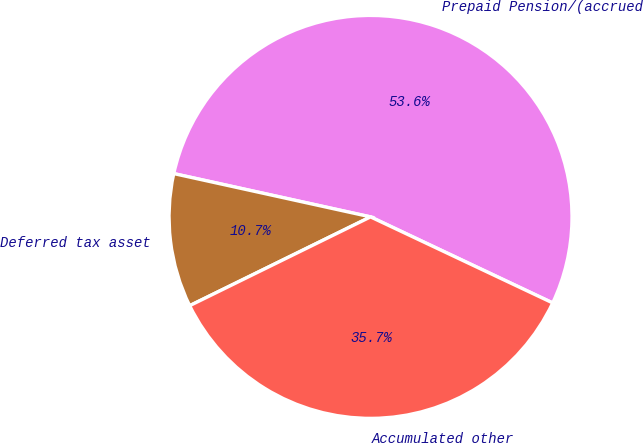<chart> <loc_0><loc_0><loc_500><loc_500><pie_chart><fcel>Prepaid Pension/(accrued<fcel>Deferred tax asset<fcel>Accumulated other<nl><fcel>53.57%<fcel>10.71%<fcel>35.71%<nl></chart> 